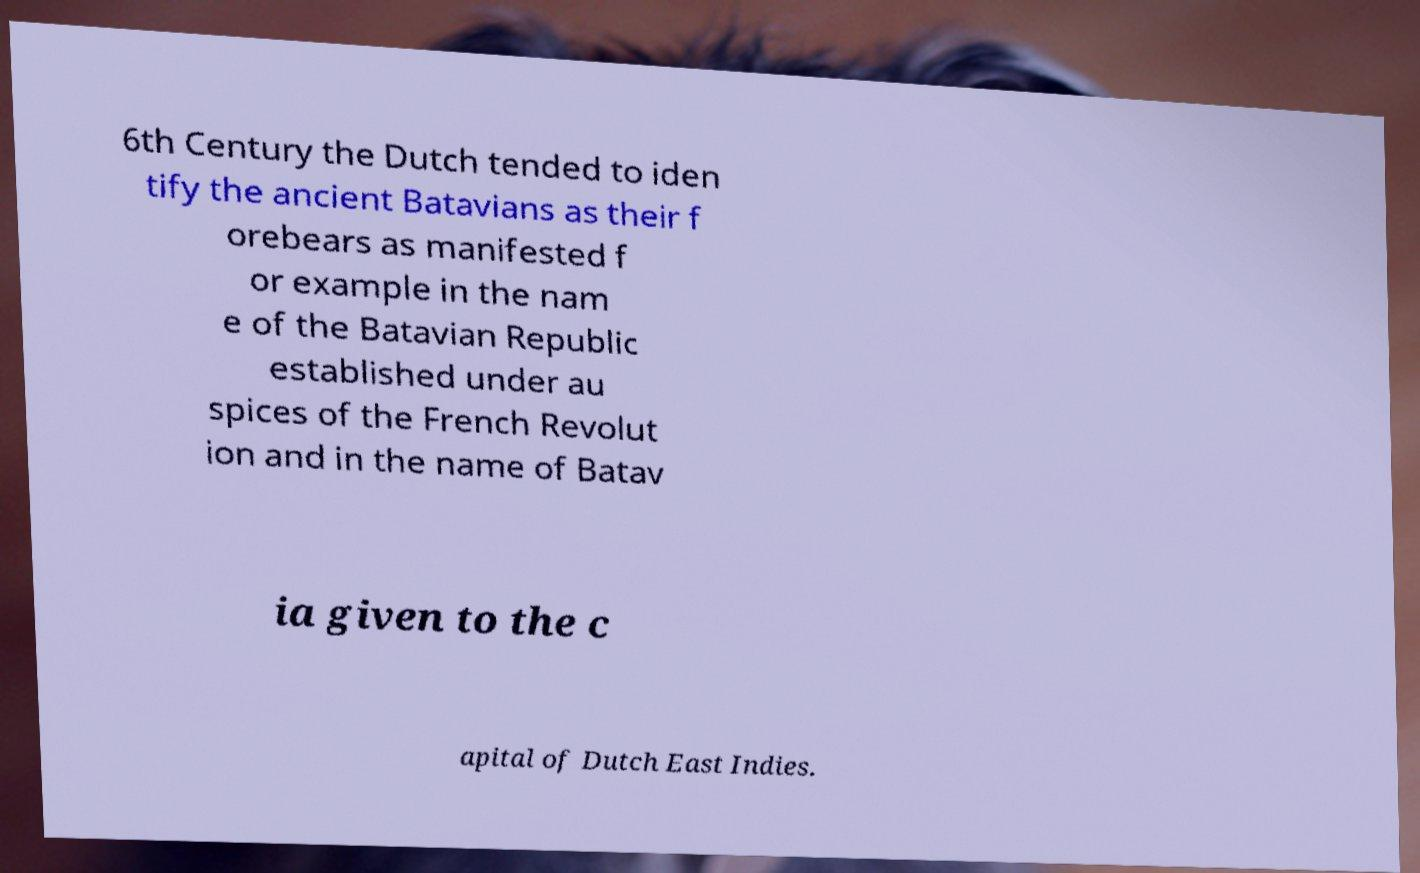Can you read and provide the text displayed in the image?This photo seems to have some interesting text. Can you extract and type it out for me? 6th Century the Dutch tended to iden tify the ancient Batavians as their f orebears as manifested f or example in the nam e of the Batavian Republic established under au spices of the French Revolut ion and in the name of Batav ia given to the c apital of Dutch East Indies. 